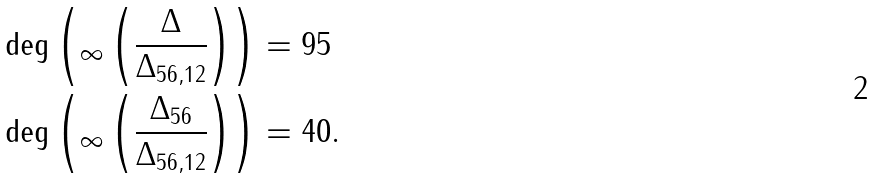<formula> <loc_0><loc_0><loc_500><loc_500>& \deg \left ( _ { \infty } \left ( \frac { \Delta } { \Delta _ { 5 6 , 1 2 } } \right ) \right ) = 9 5 \\ & \deg \left ( _ { \infty } \left ( \frac { \Delta _ { 5 6 } } { \Delta _ { 5 6 , 1 2 } } \right ) \right ) = 4 0 .</formula> 